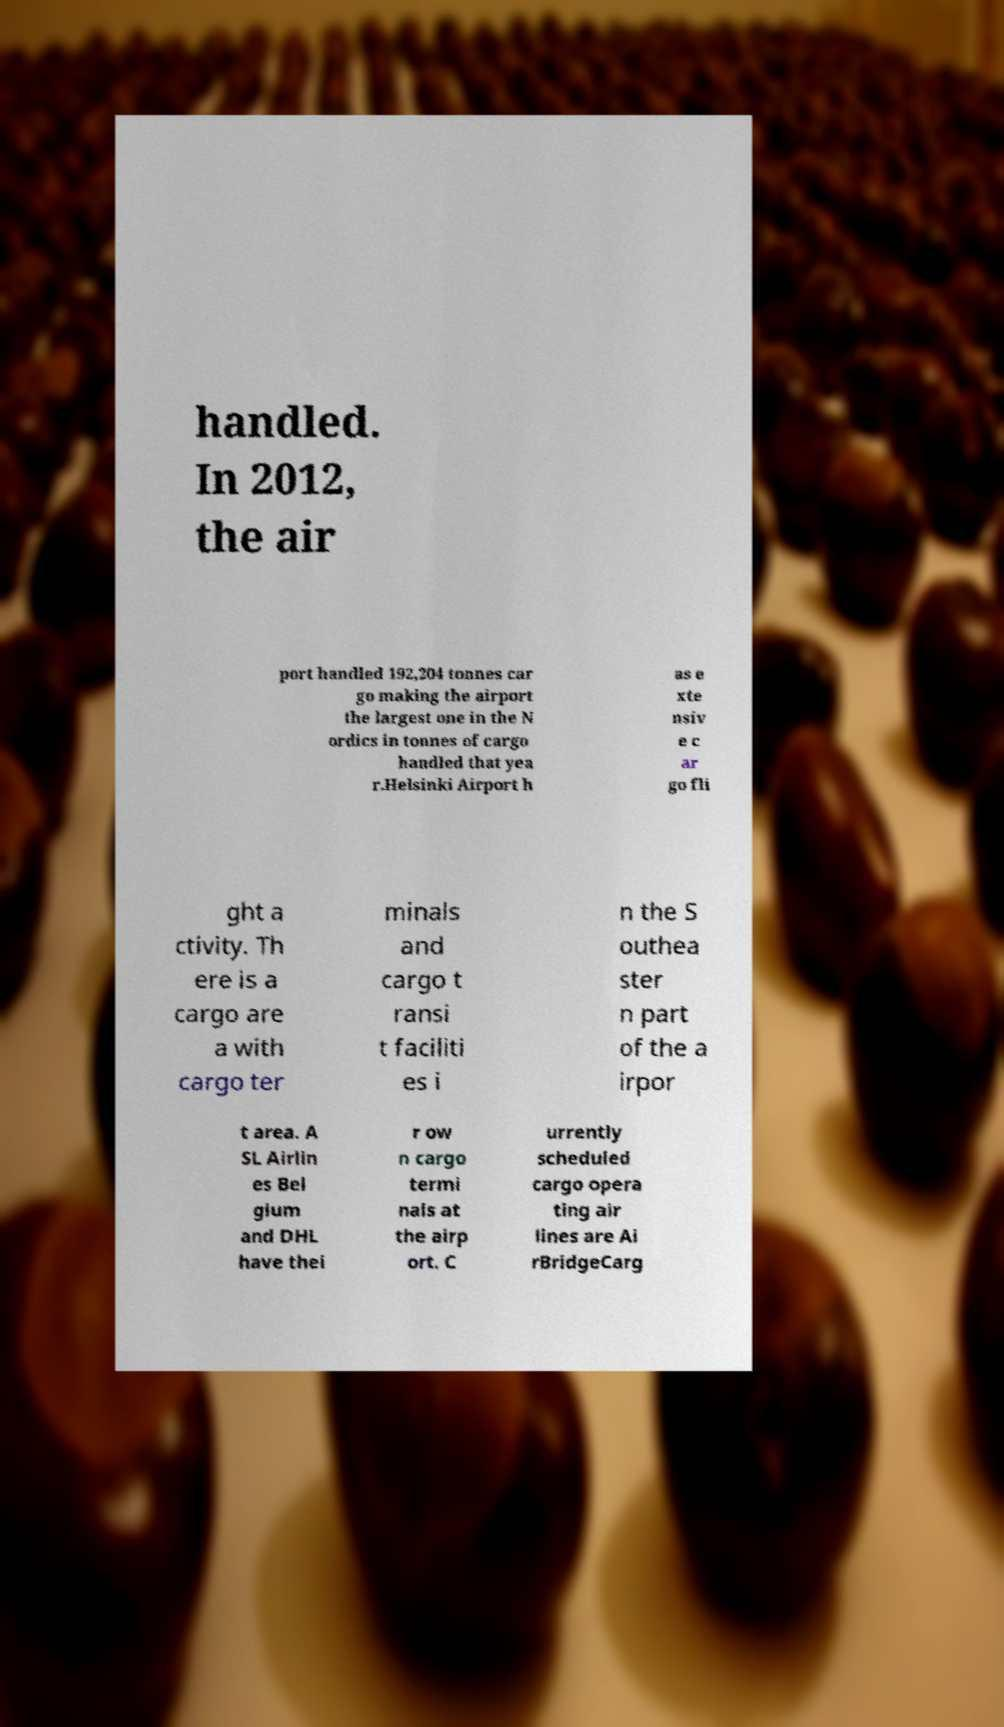There's text embedded in this image that I need extracted. Can you transcribe it verbatim? handled. In 2012, the air port handled 192,204 tonnes car go making the airport the largest one in the N ordics in tonnes of cargo handled that yea r.Helsinki Airport h as e xte nsiv e c ar go fli ght a ctivity. Th ere is a cargo are a with cargo ter minals and cargo t ransi t faciliti es i n the S outhea ster n part of the a irpor t area. A SL Airlin es Bel gium and DHL have thei r ow n cargo termi nals at the airp ort. C urrently scheduled cargo opera ting air lines are Ai rBridgeCarg 